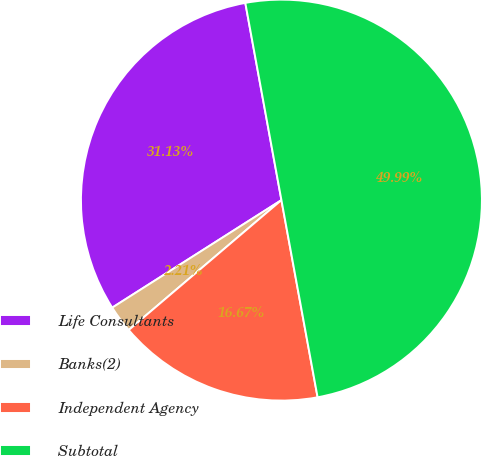<chart> <loc_0><loc_0><loc_500><loc_500><pie_chart><fcel>Life Consultants<fcel>Banks(2)<fcel>Independent Agency<fcel>Subtotal<nl><fcel>31.13%<fcel>2.21%<fcel>16.67%<fcel>50.0%<nl></chart> 